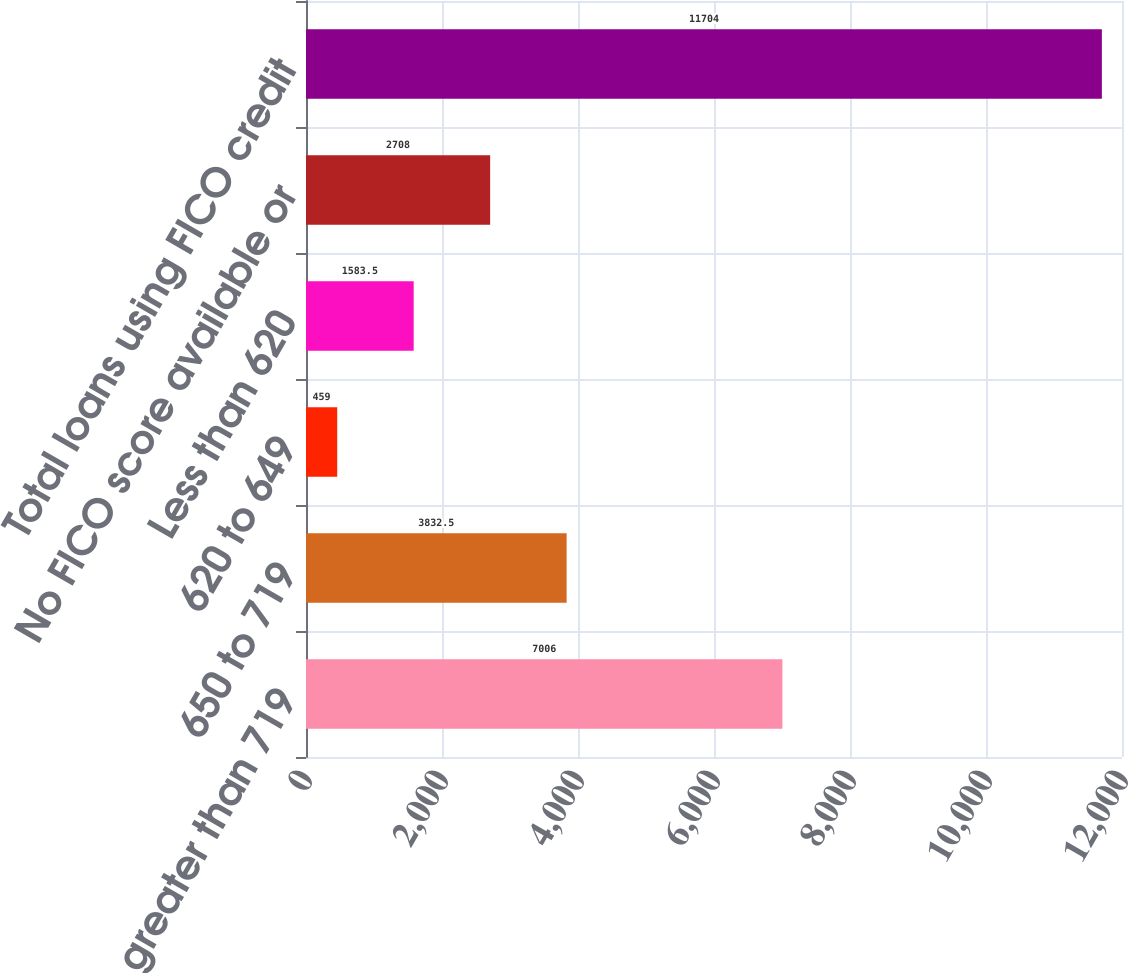<chart> <loc_0><loc_0><loc_500><loc_500><bar_chart><fcel>FICO score greater than 719<fcel>650 to 719<fcel>620 to 649<fcel>Less than 620<fcel>No FICO score available or<fcel>Total loans using FICO credit<nl><fcel>7006<fcel>3832.5<fcel>459<fcel>1583.5<fcel>2708<fcel>11704<nl></chart> 